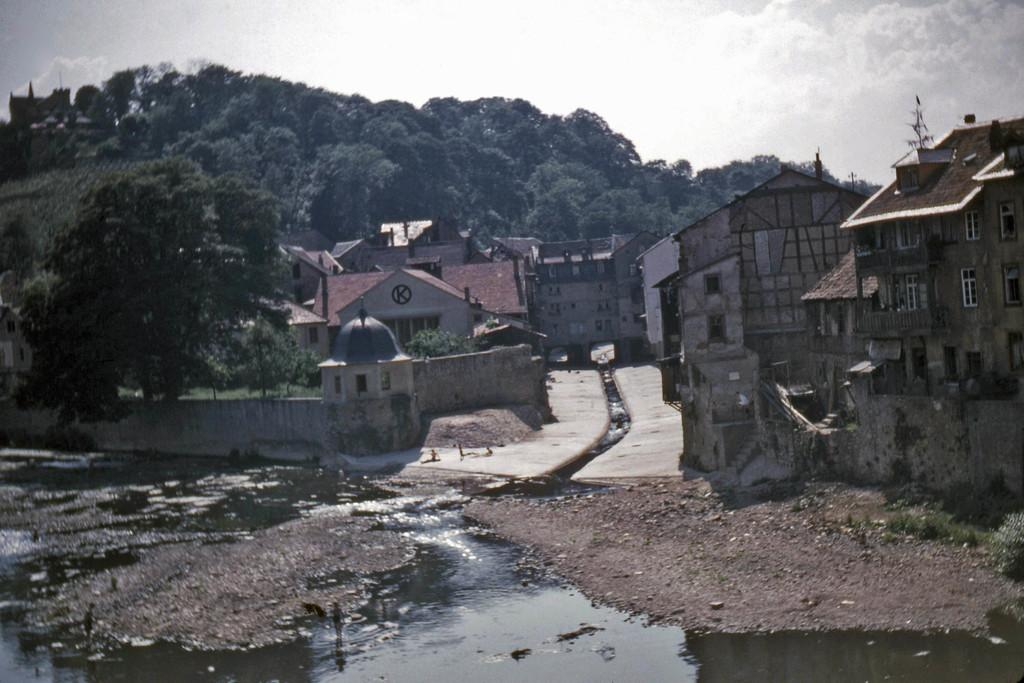What is present at the bottom of the image? There is water at the bottom of the image. What can be seen in the background of the image? There are trees and buildings in the background of the image. What is visible at the top of the image? The sky is visible at the top of the image. What type of vegetation is present in the image? There is grass in the image. Who is the owner of the wound in the image? There is no wound present in the image. What type of pipe can be seen in the image? There is no pipe present in the image. 